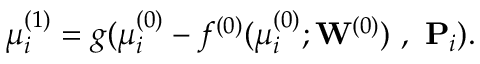Convert formula to latex. <formula><loc_0><loc_0><loc_500><loc_500>\mu _ { i } ^ { ( 1 ) } = g ( \mu _ { i } ^ { ( 0 ) } - f ^ { ( 0 ) } ( \mu _ { i } ^ { ( 0 ) } ; { \mathbf W } ^ { ( 0 ) } ) , P _ { i } ) .</formula> 